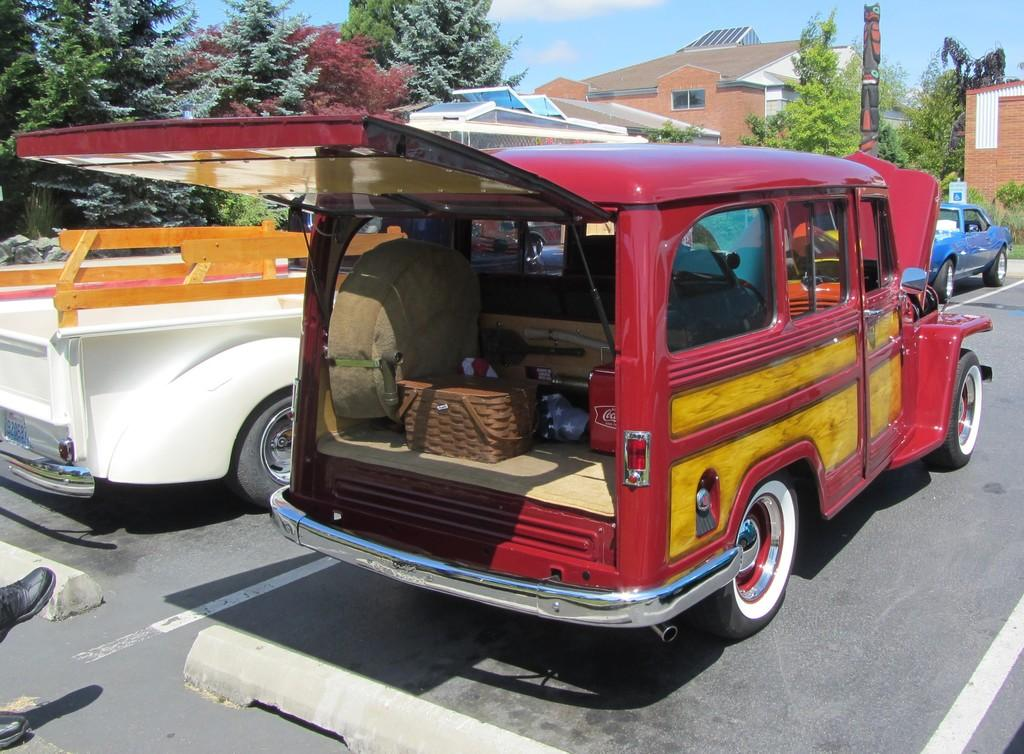What can be seen in the image? There are vehicles in the image. What is visible in the background of the image? There are trees and buildings in the background of the image. Where are the shoes of a person located in the image? The shoes of a person are in the left corner of the image. Can you tell me how many horses are present in the image? There are no horses present in the image. What type of cork is used to secure the place in the image? There is no cork or reference to a specific place in the image. 